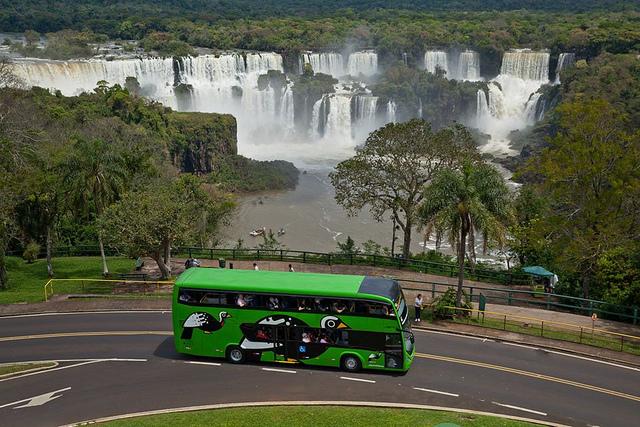Where is the Grand Canyon?
Quick response, please. Arizona. Are the waterfalls beautiful?
Quick response, please. Yes. Which way is the bus driving?
Quick response, please. Right. What is white in water?
Write a very short answer. Foam. 